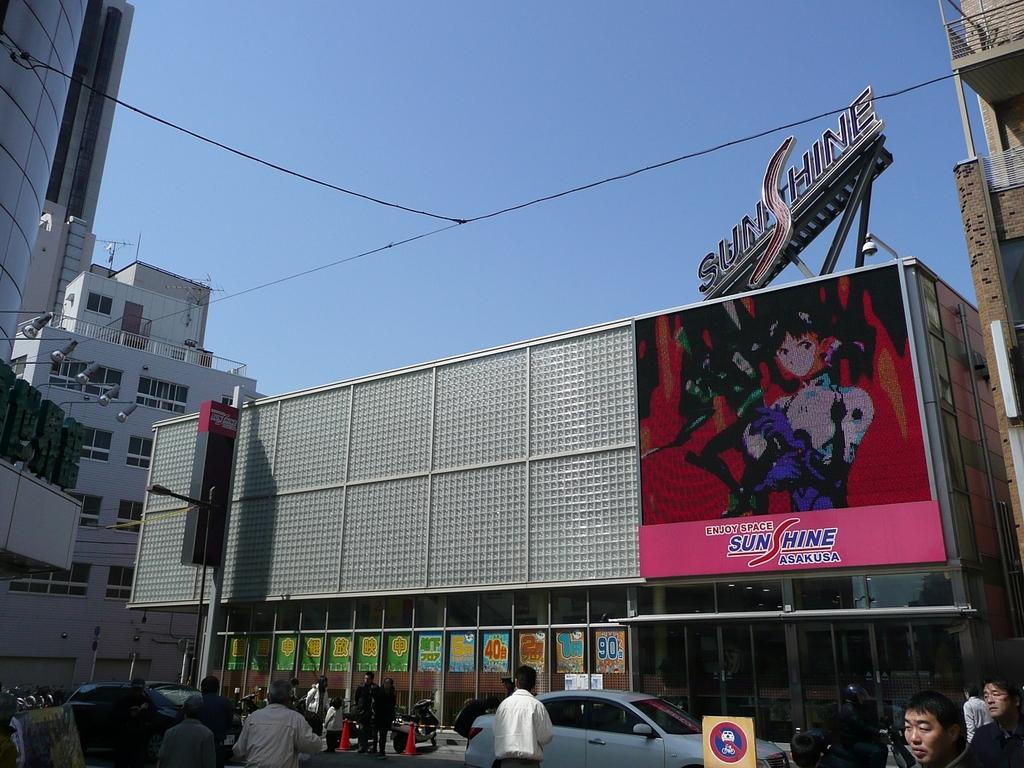<image>
Present a compact description of the photo's key features. An electronic billboard with a sign above it with the word SunShine. 